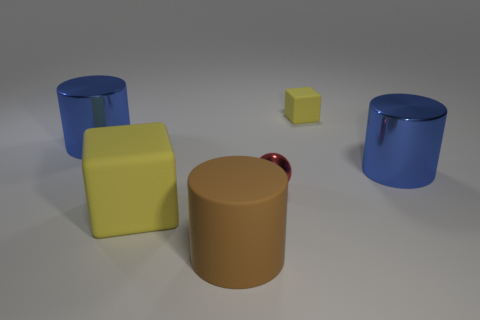Subtract all big blue shiny cylinders. How many cylinders are left? 1 Add 4 brown metallic things. How many objects exist? 10 Subtract all balls. How many objects are left? 5 Subtract all brown cylinders. How many cylinders are left? 2 Subtract all purple cubes. Subtract all cyan cylinders. How many cubes are left? 2 Subtract all blue blocks. How many gray cylinders are left? 0 Subtract all big brown metallic cubes. Subtract all brown matte cylinders. How many objects are left? 5 Add 4 tiny spheres. How many tiny spheres are left? 5 Add 4 rubber cubes. How many rubber cubes exist? 6 Subtract 0 purple spheres. How many objects are left? 6 